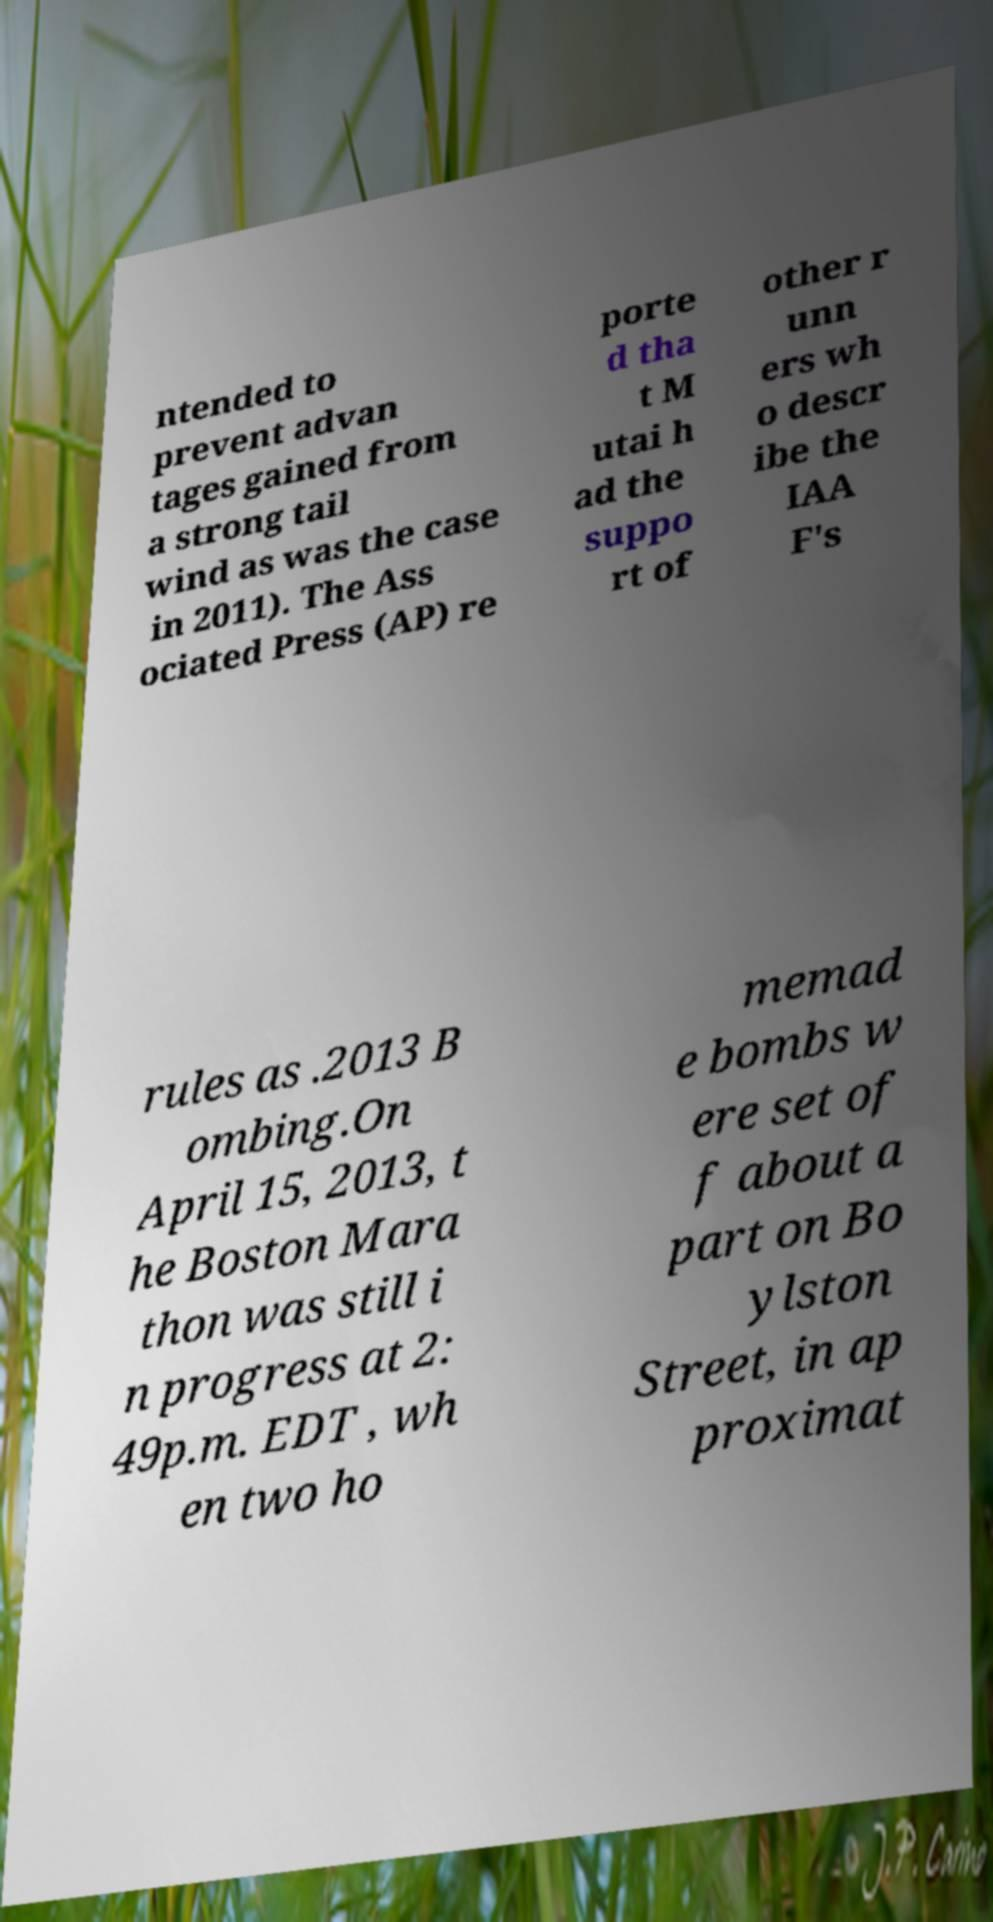Can you read and provide the text displayed in the image?This photo seems to have some interesting text. Can you extract and type it out for me? ntended to prevent advan tages gained from a strong tail wind as was the case in 2011). The Ass ociated Press (AP) re porte d tha t M utai h ad the suppo rt of other r unn ers wh o descr ibe the IAA F's rules as .2013 B ombing.On April 15, 2013, t he Boston Mara thon was still i n progress at 2: 49p.m. EDT , wh en two ho memad e bombs w ere set of f about a part on Bo ylston Street, in ap proximat 